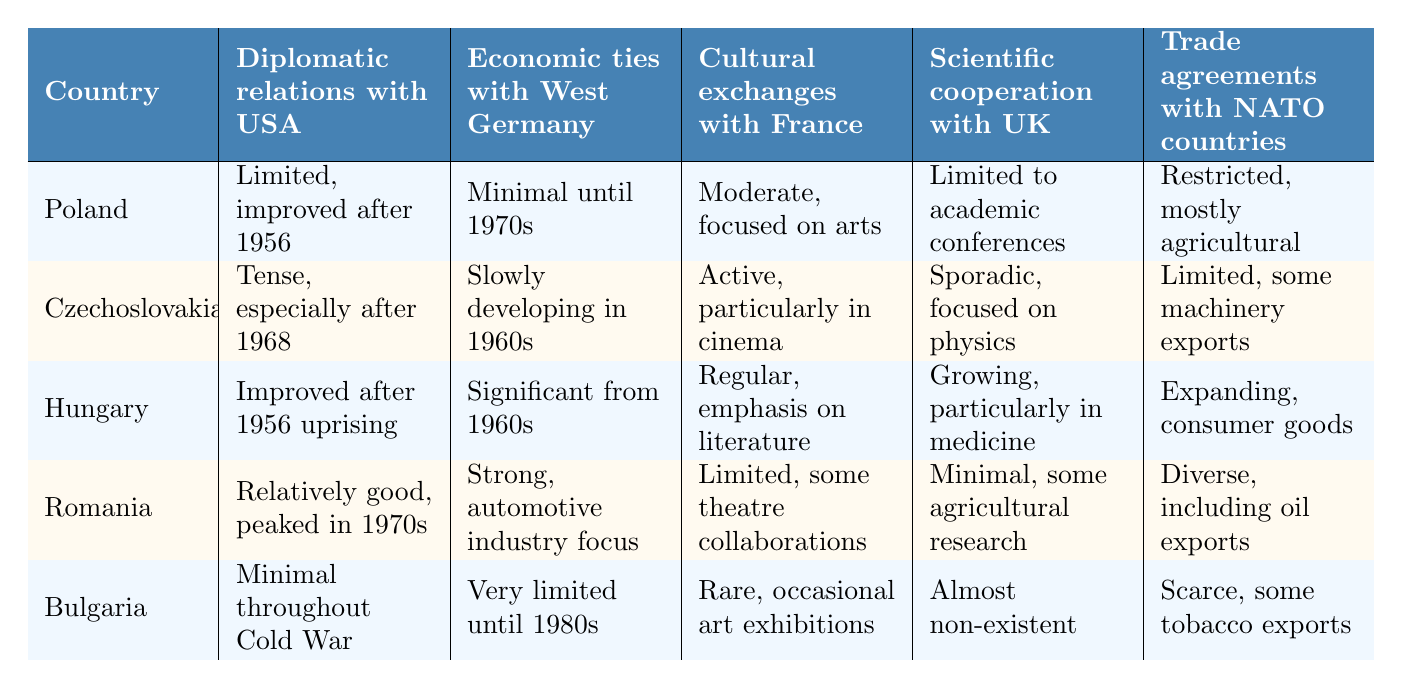What were the diplomatic relations with the USA for Poland? The table indicates that Poland had limited diplomatic relations with the USA, which improved after 1956.
Answer: Limited, improved after 1956 Which country had the most significant economic ties with West Germany starting from the 1960s? According to the table, Hungary's economic ties with West Germany were significant from the 1960s.
Answer: Hungary Did Bulgaria have any significant cultural exchanges with France during the Cold War? The table states that Bulgaria had rare cultural exchanges with France, consisting of occasional art exhibitions, so it was not significant.
Answer: No What is the relationship between Poland's scientific cooperation with the UK and its diplomatic relations with the USA? Poland had limited scientific cooperation with the UK, while its diplomatic relations with the USA were limited but improved after 1956. Both aspects indicate a cautious engagement with Western powers.
Answer: Cautious engagement Which country had a relatively good relationship with the USA that peaked in the 1970s? The table specifies that Romania had relatively good diplomatic relations with the USA, which peaked in the 1970s.
Answer: Romania Count the number of countries that had minimal scientific cooperation with the UK. Referring to the table, Bulgaria and Romania both had minimal or almost non-existent scientific cooperation with the UK, indicating a total of two countries.
Answer: 2 Was there any country with significant trade agreements with NATO countries? The table shows that Hungary had expanding trade agreements with NATO countries. Thus, the answer is yes.
Answer: Yes What was the cultural exchange emphasis for Hungary with France? The table indicates that Hungary's cultural exchanges with France had a regular emphasis on literature.
Answer: Literature Which country had the least economic ties with West Germany until the 1980s? The data shows that Bulgaria had very limited economic ties with West Germany until the 1980s, indicating it had the least among the listed countries.
Answer: Bulgaria 